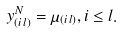<formula> <loc_0><loc_0><loc_500><loc_500>y _ { ( i \, l ) } ^ { N } = \mu _ { ( i \, l ) } , i \leq l .</formula> 